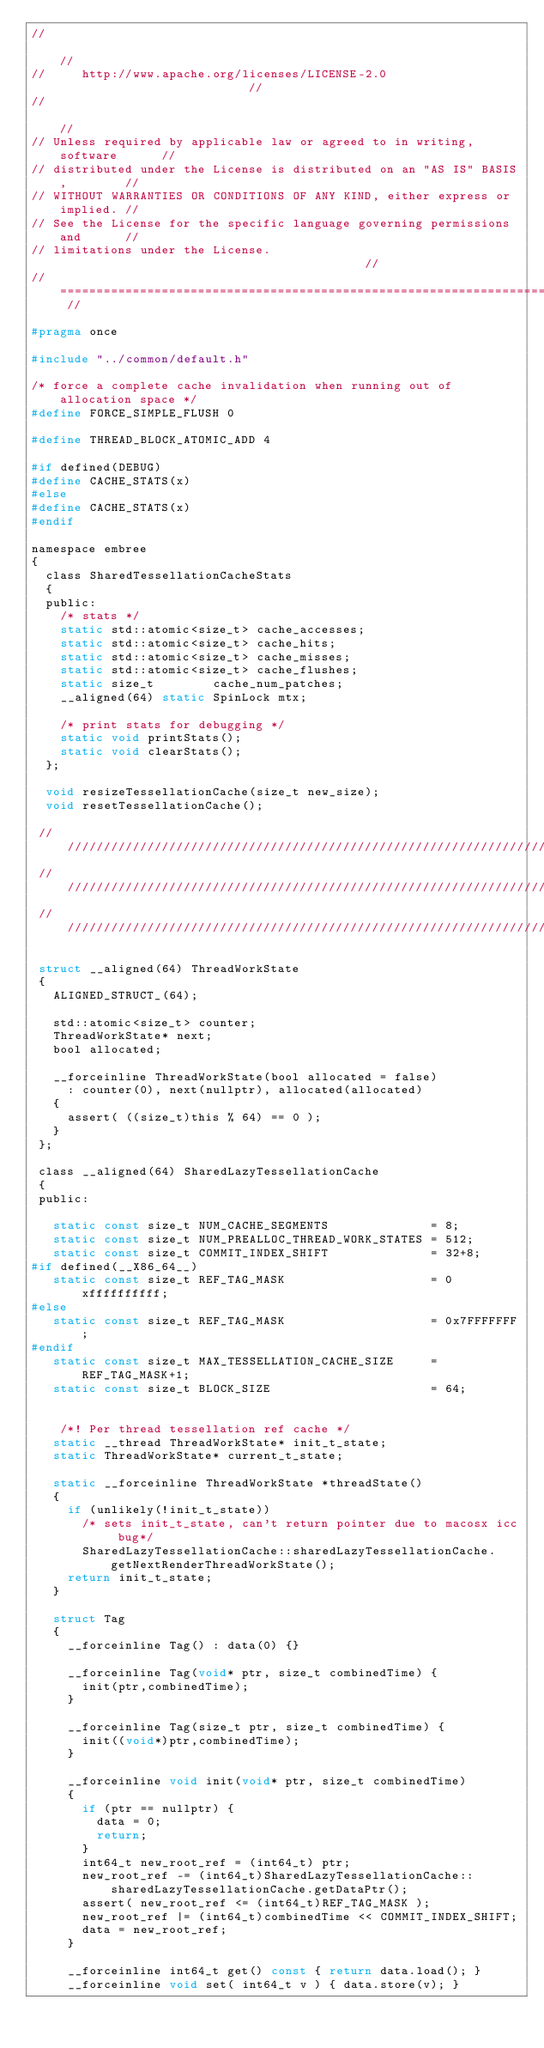Convert code to text. <code><loc_0><loc_0><loc_500><loc_500><_C_>//                                                                          //
//     http://www.apache.org/licenses/LICENSE-2.0                           //
//                                                                          //
// Unless required by applicable law or agreed to in writing, software      //
// distributed under the License is distributed on an "AS IS" BASIS,        //
// WITHOUT WARRANTIES OR CONDITIONS OF ANY KIND, either express or implied. //
// See the License for the specific language governing permissions and      //
// limitations under the License.                                           //
// ======================================================================== //

#pragma once

#include "../common/default.h"

/* force a complete cache invalidation when running out of allocation space */
#define FORCE_SIMPLE_FLUSH 0

#define THREAD_BLOCK_ATOMIC_ADD 4

#if defined(DEBUG)
#define CACHE_STATS(x) 
#else
#define CACHE_STATS(x) 
#endif

namespace embree
{
  class SharedTessellationCacheStats
  {
  public:
    /* stats */
    static std::atomic<size_t> cache_accesses;
    static std::atomic<size_t> cache_hits;
    static std::atomic<size_t> cache_misses;
    static std::atomic<size_t> cache_flushes;                
    static size_t        cache_num_patches;
    __aligned(64) static SpinLock mtx;
    
    /* print stats for debugging */                 
    static void printStats();
    static void clearStats();
  };
  
  void resizeTessellationCache(size_t new_size);
  void resetTessellationCache();
  
 ////////////////////////////////////////////////////////////////////////////////
 ////////////////////////////////////////////////////////////////////////////////
 ////////////////////////////////////////////////////////////////////////////////

 struct __aligned(64) ThreadWorkState 
 {
   ALIGNED_STRUCT_(64);

   std::atomic<size_t> counter;
   ThreadWorkState* next;
   bool allocated;

   __forceinline ThreadWorkState(bool allocated = false) 
     : counter(0), next(nullptr), allocated(allocated) 
   {
     assert( ((size_t)this % 64) == 0 ); 
   }   
 };

 class __aligned(64) SharedLazyTessellationCache 
 {
 public:
   
   static const size_t NUM_CACHE_SEGMENTS              = 8;
   static const size_t NUM_PREALLOC_THREAD_WORK_STATES = 512;
   static const size_t COMMIT_INDEX_SHIFT              = 32+8;
#if defined(__X86_64__)
   static const size_t REF_TAG_MASK                    = 0xffffffffff;
#else
   static const size_t REF_TAG_MASK                    = 0x7FFFFFFF;
#endif
   static const size_t MAX_TESSELLATION_CACHE_SIZE     = REF_TAG_MASK+1;
   static const size_t BLOCK_SIZE                      = 64;
   

    /*! Per thread tessellation ref cache */
   static __thread ThreadWorkState* init_t_state;
   static ThreadWorkState* current_t_state;
   
   static __forceinline ThreadWorkState *threadState() 
   {
     if (unlikely(!init_t_state))
       /* sets init_t_state, can't return pointer due to macosx icc bug*/
       SharedLazyTessellationCache::sharedLazyTessellationCache.getNextRenderThreadWorkState();
     return init_t_state;
   }

   struct Tag
   {
     __forceinline Tag() : data(0) {}

     __forceinline Tag(void* ptr, size_t combinedTime) { 
       init(ptr,combinedTime);
     }

     __forceinline Tag(size_t ptr, size_t combinedTime) {
       init((void*)ptr,combinedTime); 
     }

     __forceinline void init(void* ptr, size_t combinedTime)
     {
       if (ptr == nullptr) {
         data = 0;
         return;
       }
       int64_t new_root_ref = (int64_t) ptr;
       new_root_ref -= (int64_t)SharedLazyTessellationCache::sharedLazyTessellationCache.getDataPtr();                                
       assert( new_root_ref <= (int64_t)REF_TAG_MASK );
       new_root_ref |= (int64_t)combinedTime << COMMIT_INDEX_SHIFT; 
       data = new_root_ref;
     }

     __forceinline int64_t get() const { return data.load(); }
     __forceinline void set( int64_t v ) { data.store(v); }</code> 